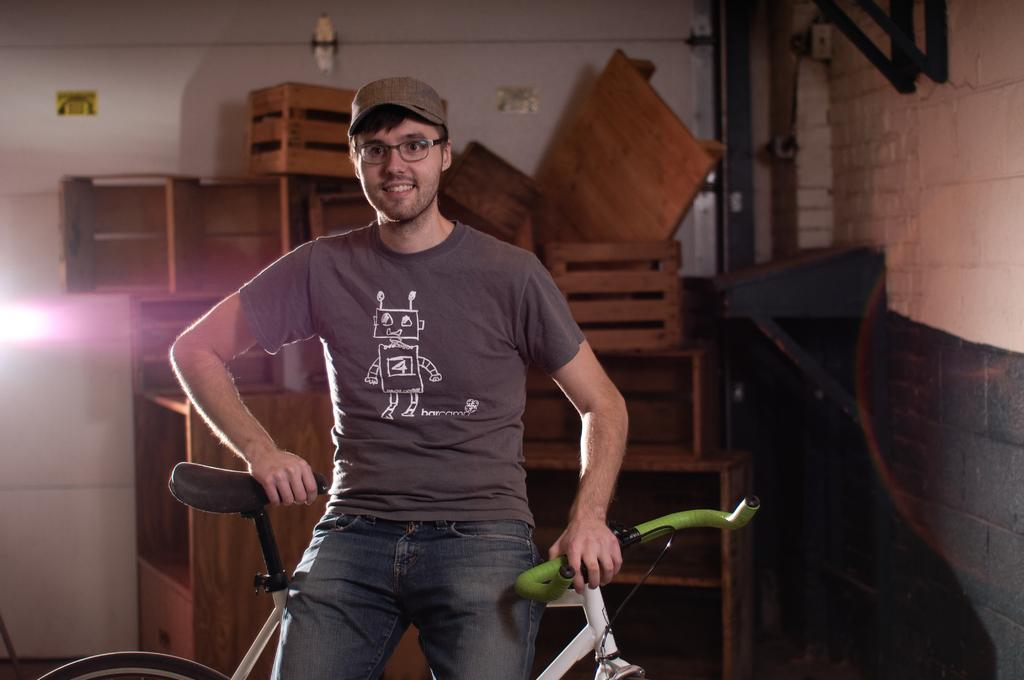What is the main subject of the image? There is a person in the image. What is the person doing in the image? The person is sitting on a cycle. What can be seen in front of a wall in the image? There are boxes in front of a wall in the image. What is located in the top right of the image? There are pipes in the top right of the image. What type of potato is being peeled by the person in the image? There is no potato present in the image, and the person is not shown peeling anything. 